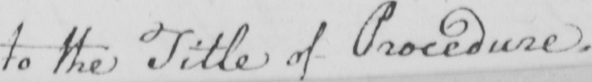Please transcribe the handwritten text in this image. to the Title of Procedure . 